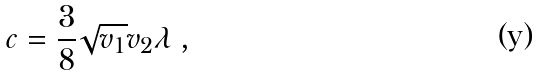Convert formula to latex. <formula><loc_0><loc_0><loc_500><loc_500>c = \frac { 3 } { 8 } \sqrt { v _ { 1 } } v _ { 2 } \lambda \, ,</formula> 